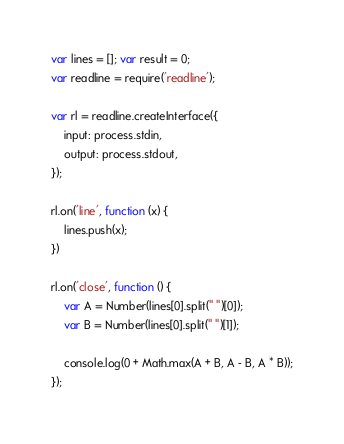<code> <loc_0><loc_0><loc_500><loc_500><_JavaScript_>var lines = []; var result = 0;
var readline = require('readline');

var rl = readline.createInterface({
    input: process.stdin,
    output: process.stdout,
});

rl.on('line', function (x) {
    lines.push(x);
})

rl.on('close', function () {
    var A = Number(lines[0].split(" ")[0]);
    var B = Number(lines[0].split(" ")[1]);

    console.log(0 + Math.max(A + B, A - B, A * B));
});</code> 